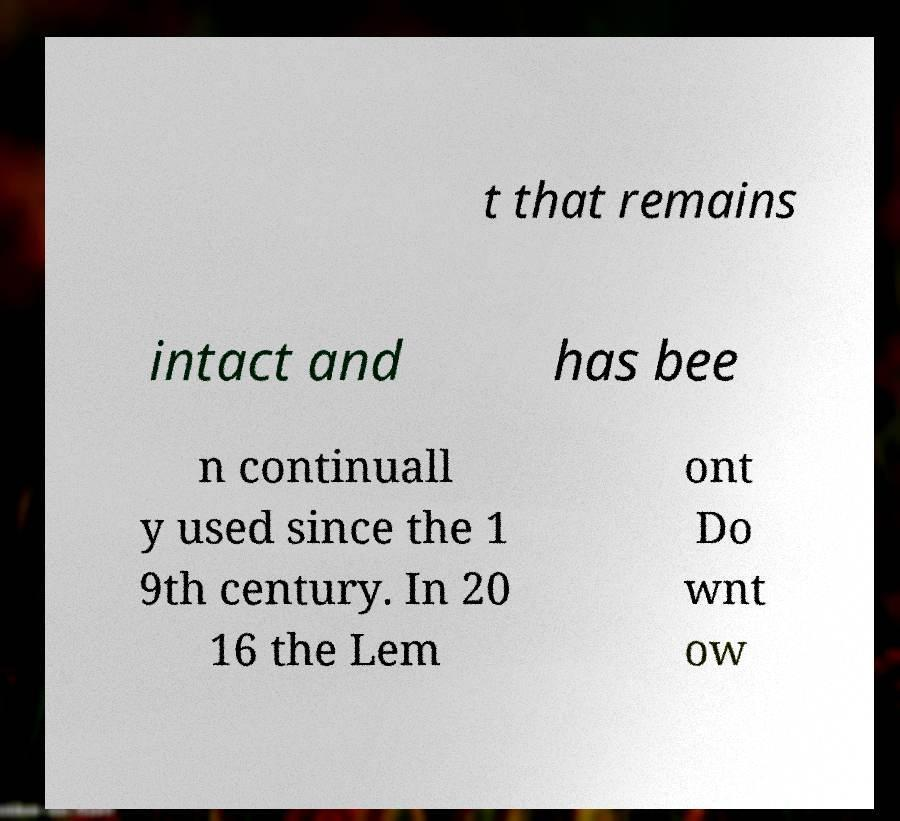Could you assist in decoding the text presented in this image and type it out clearly? t that remains intact and has bee n continuall y used since the 1 9th century. In 20 16 the Lem ont Do wnt ow 